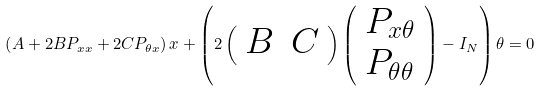Convert formula to latex. <formula><loc_0><loc_0><loc_500><loc_500>\left ( A + 2 B P _ { x x } + 2 C P _ { \theta x } \right ) x + \left ( 2 \left ( \begin{array} { l l } B & C \end{array} \right ) \left ( \begin{array} { l } P _ { x \theta } \\ P _ { \theta \theta } \end{array} \right ) - I _ { N } \right ) \theta = 0</formula> 